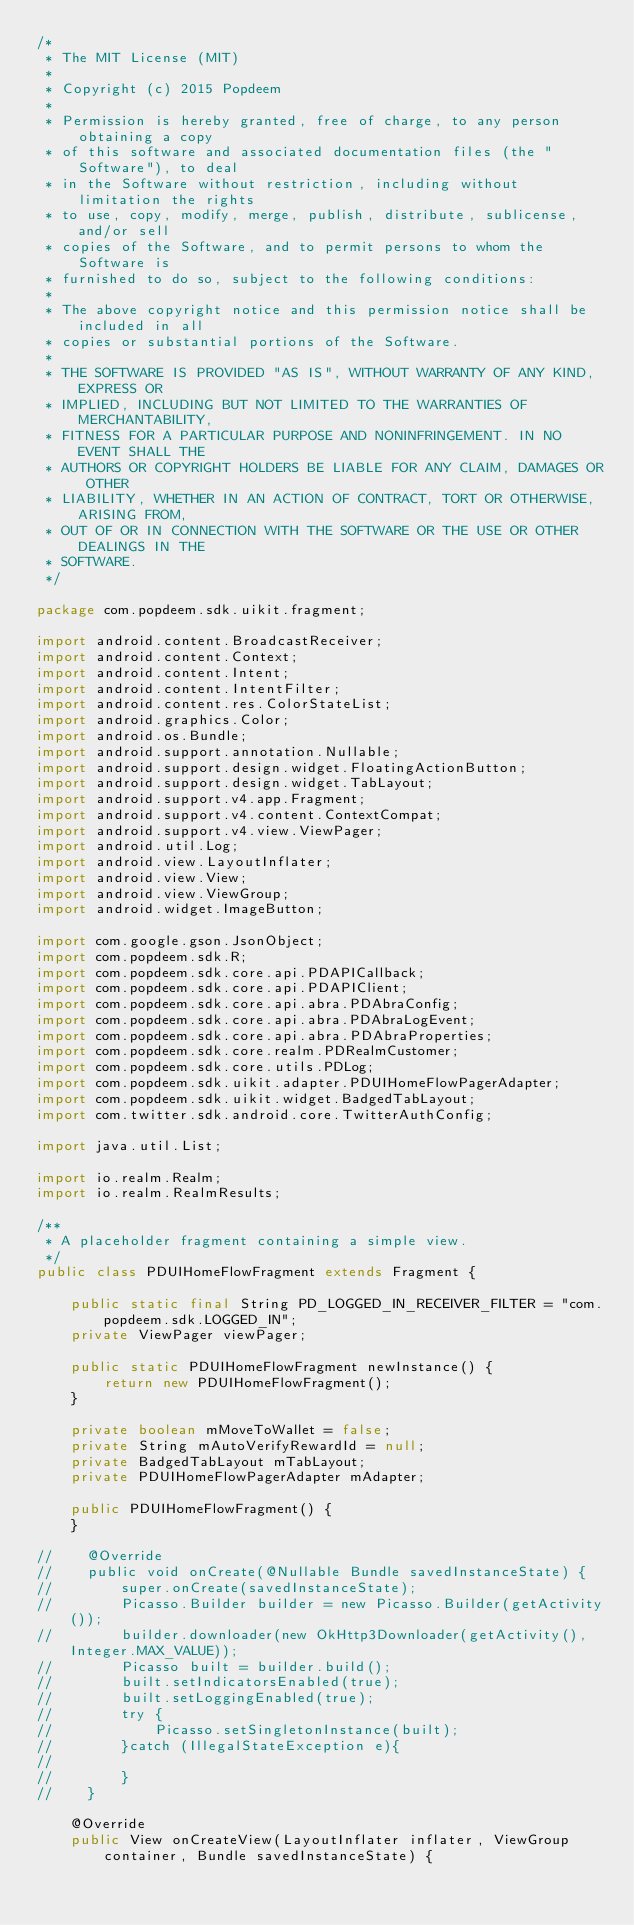<code> <loc_0><loc_0><loc_500><loc_500><_Java_>/*
 * The MIT License (MIT)
 *
 * Copyright (c) 2015 Popdeem
 *
 * Permission is hereby granted, free of charge, to any person obtaining a copy
 * of this software and associated documentation files (the "Software"), to deal
 * in the Software without restriction, including without limitation the rights
 * to use, copy, modify, merge, publish, distribute, sublicense, and/or sell
 * copies of the Software, and to permit persons to whom the Software is
 * furnished to do so, subject to the following conditions:
 *
 * The above copyright notice and this permission notice shall be included in all
 * copies or substantial portions of the Software.
 *
 * THE SOFTWARE IS PROVIDED "AS IS", WITHOUT WARRANTY OF ANY KIND, EXPRESS OR
 * IMPLIED, INCLUDING BUT NOT LIMITED TO THE WARRANTIES OF MERCHANTABILITY,
 * FITNESS FOR A PARTICULAR PURPOSE AND NONINFRINGEMENT. IN NO EVENT SHALL THE
 * AUTHORS OR COPYRIGHT HOLDERS BE LIABLE FOR ANY CLAIM, DAMAGES OR OTHER
 * LIABILITY, WHETHER IN AN ACTION OF CONTRACT, TORT OR OTHERWISE, ARISING FROM,
 * OUT OF OR IN CONNECTION WITH THE SOFTWARE OR THE USE OR OTHER DEALINGS IN THE
 * SOFTWARE.
 */

package com.popdeem.sdk.uikit.fragment;

import android.content.BroadcastReceiver;
import android.content.Context;
import android.content.Intent;
import android.content.IntentFilter;
import android.content.res.ColorStateList;
import android.graphics.Color;
import android.os.Bundle;
import android.support.annotation.Nullable;
import android.support.design.widget.FloatingActionButton;
import android.support.design.widget.TabLayout;
import android.support.v4.app.Fragment;
import android.support.v4.content.ContextCompat;
import android.support.v4.view.ViewPager;
import android.util.Log;
import android.view.LayoutInflater;
import android.view.View;
import android.view.ViewGroup;
import android.widget.ImageButton;

import com.google.gson.JsonObject;
import com.popdeem.sdk.R;
import com.popdeem.sdk.core.api.PDAPICallback;
import com.popdeem.sdk.core.api.PDAPIClient;
import com.popdeem.sdk.core.api.abra.PDAbraConfig;
import com.popdeem.sdk.core.api.abra.PDAbraLogEvent;
import com.popdeem.sdk.core.api.abra.PDAbraProperties;
import com.popdeem.sdk.core.realm.PDRealmCustomer;
import com.popdeem.sdk.core.utils.PDLog;
import com.popdeem.sdk.uikit.adapter.PDUIHomeFlowPagerAdapter;
import com.popdeem.sdk.uikit.widget.BadgedTabLayout;
import com.twitter.sdk.android.core.TwitterAuthConfig;

import java.util.List;

import io.realm.Realm;
import io.realm.RealmResults;

/**
 * A placeholder fragment containing a simple view.
 */
public class PDUIHomeFlowFragment extends Fragment {

    public static final String PD_LOGGED_IN_RECEIVER_FILTER = "com.popdeem.sdk.LOGGED_IN";
    private ViewPager viewPager;

    public static PDUIHomeFlowFragment newInstance() {
        return new PDUIHomeFlowFragment();
    }

    private boolean mMoveToWallet = false;
    private String mAutoVerifyRewardId = null;
    private BadgedTabLayout mTabLayout;
    private PDUIHomeFlowPagerAdapter mAdapter;

    public PDUIHomeFlowFragment() {
    }

//    @Override
//    public void onCreate(@Nullable Bundle savedInstanceState) {
//        super.onCreate(savedInstanceState);
//        Picasso.Builder builder = new Picasso.Builder(getActivity());
//        builder.downloader(new OkHttp3Downloader(getActivity(),Integer.MAX_VALUE));
//        Picasso built = builder.build();
//        built.setIndicatorsEnabled(true);
//        built.setLoggingEnabled(true);
//        try {
//            Picasso.setSingletonInstance(built);
//        }catch (IllegalStateException e){
//
//        }
//    }

    @Override
    public View onCreateView(LayoutInflater inflater, ViewGroup container, Bundle savedInstanceState) {</code> 